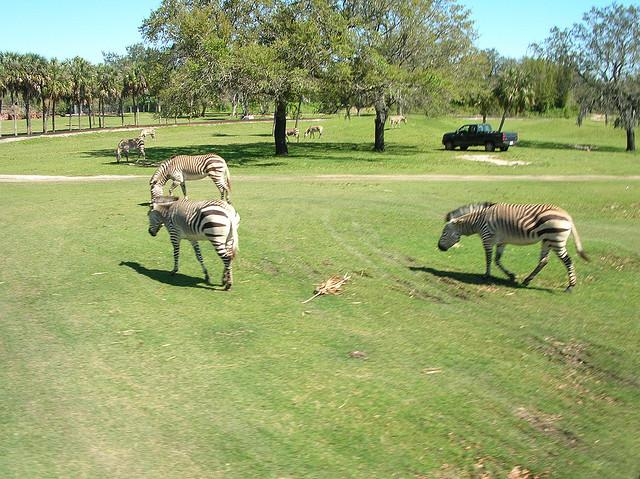What do the animals have?

Choices:
A) long necks
B) stingers
C) stripes
D) talons stripes 